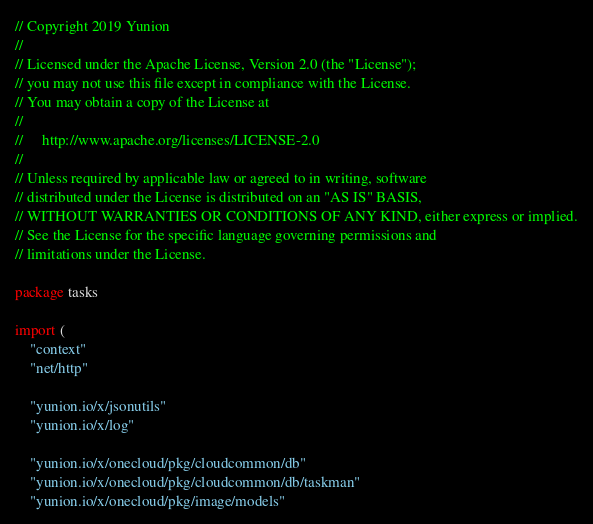Convert code to text. <code><loc_0><loc_0><loc_500><loc_500><_Go_>// Copyright 2019 Yunion
//
// Licensed under the Apache License, Version 2.0 (the "License");
// you may not use this file except in compliance with the License.
// You may obtain a copy of the License at
//
//     http://www.apache.org/licenses/LICENSE-2.0
//
// Unless required by applicable law or agreed to in writing, software
// distributed under the License is distributed on an "AS IS" BASIS,
// WITHOUT WARRANTIES OR CONDITIONS OF ANY KIND, either express or implied.
// See the License for the specific language governing permissions and
// limitations under the License.

package tasks

import (
	"context"
	"net/http"

	"yunion.io/x/jsonutils"
	"yunion.io/x/log"

	"yunion.io/x/onecloud/pkg/cloudcommon/db"
	"yunion.io/x/onecloud/pkg/cloudcommon/db/taskman"
	"yunion.io/x/onecloud/pkg/image/models"</code> 